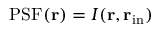<formula> <loc_0><loc_0><loc_500><loc_500>P S F ( { r } ) = I ( { r } , { r } _ { i n } )</formula> 